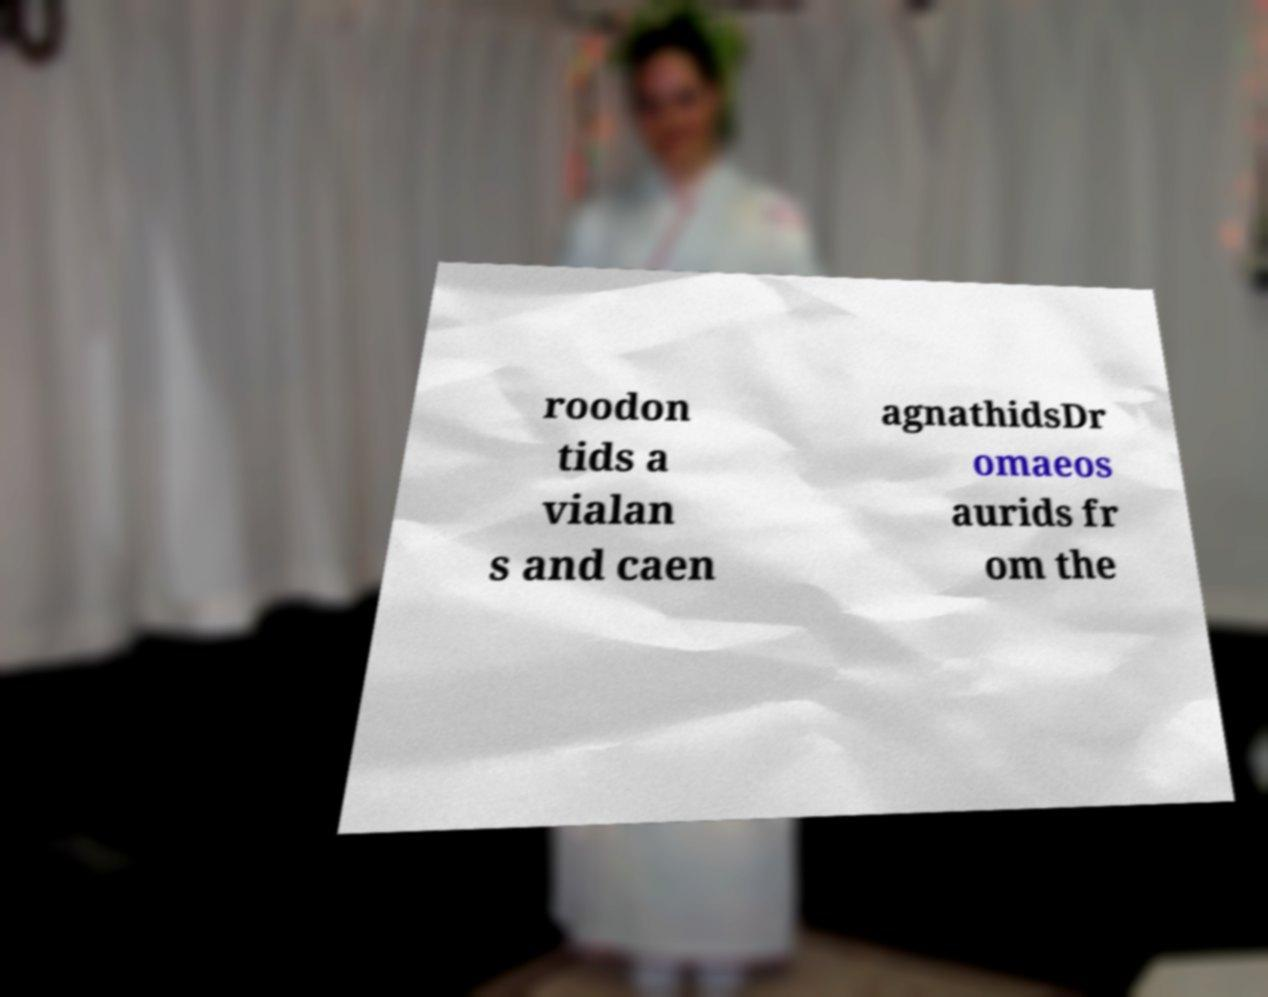Please read and relay the text visible in this image. What does it say? roodon tids a vialan s and caen agnathidsDr omaeos aurids fr om the 